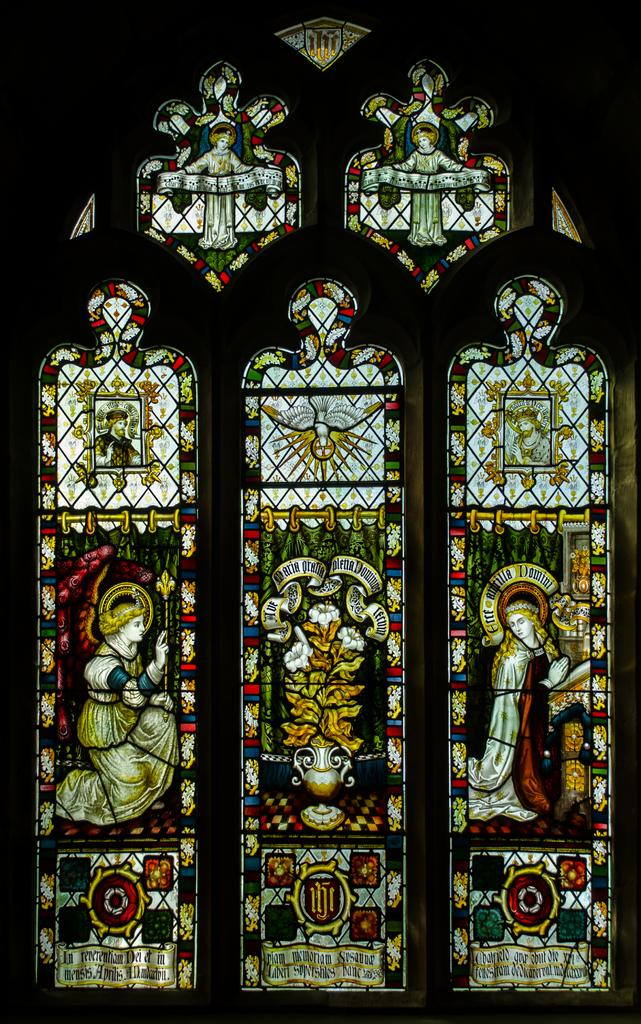What is a prominent feature on the wall in the image? There is a window with designs on it in the image. Can you describe the location of the window in the image? The window is on a wall in the image. What type of agreement is being discussed by the ghost in the image? There is no ghost present in the image, and therefore no discussion of any agreement can be observed. 